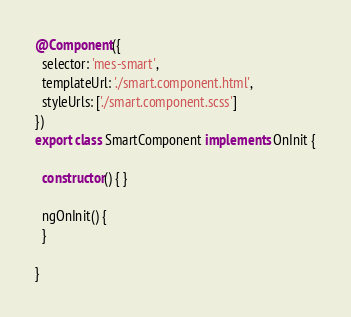<code> <loc_0><loc_0><loc_500><loc_500><_TypeScript_>@Component({
  selector: 'mes-smart',
  templateUrl: './smart.component.html',
  styleUrls: ['./smart.component.scss']
})
export class SmartComponent implements OnInit {

  constructor() { }

  ngOnInit() {
  }

}
</code> 